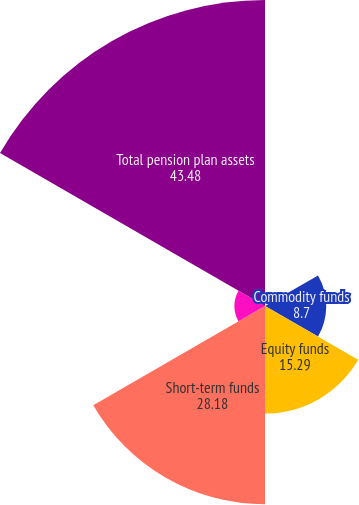<chart> <loc_0><loc_0><loc_500><loc_500><pie_chart><fcel>Debt securities<fcel>Commodity funds<fcel>Equity funds<fcel>Short-term funds<fcel>Venture capital and<fcel>Total pension plan assets<nl><fcel>0.0%<fcel>8.7%<fcel>15.29%<fcel>28.18%<fcel>4.35%<fcel>43.48%<nl></chart> 